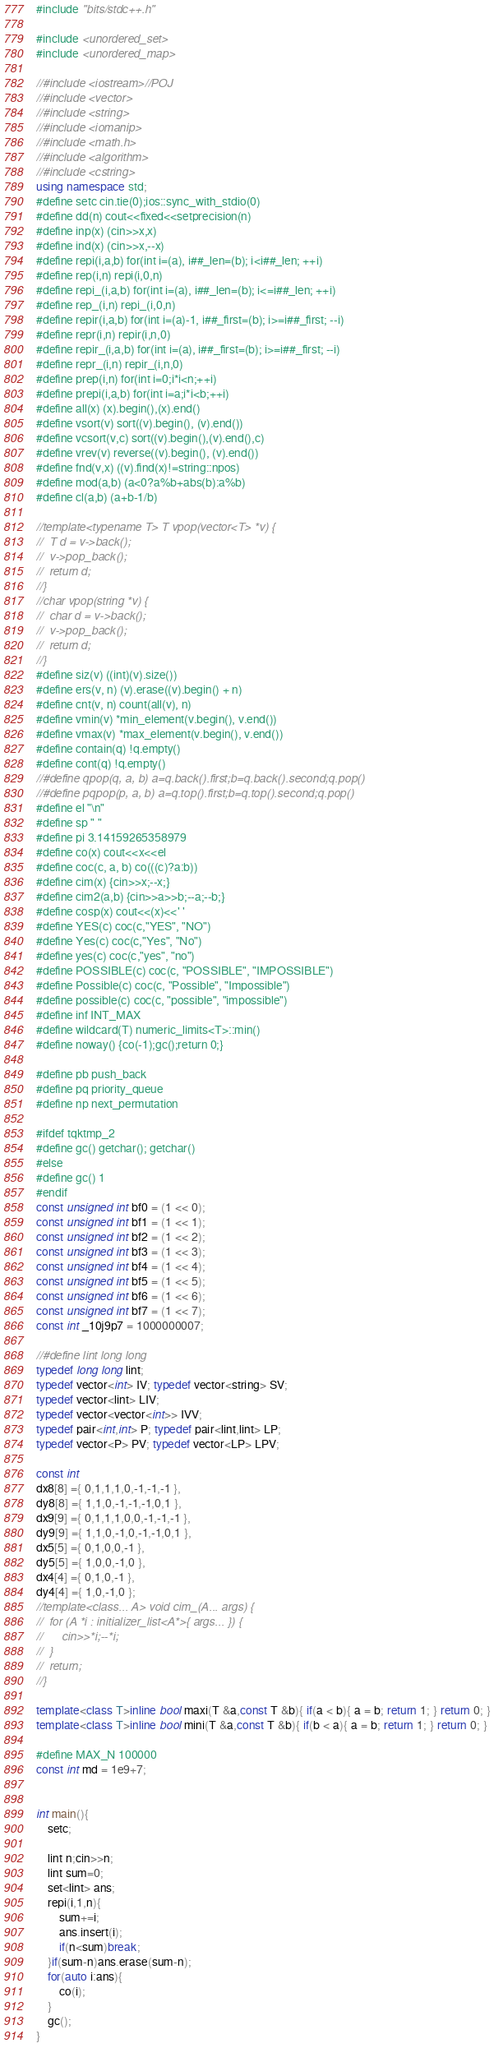Convert code to text. <code><loc_0><loc_0><loc_500><loc_500><_C++_>

#include "bits/stdc++.h"

#include <unordered_set>
#include <unordered_map>

//#include <iostream>//POJ
//#include <vector>
//#include <string>
//#include <iomanip>
//#include <math.h>
//#include <algorithm>
//#include <cstring>
using namespace std;
#define setc cin.tie(0);ios::sync_with_stdio(0)
#define dd(n) cout<<fixed<<setprecision(n)
#define inp(x) (cin>>x,x)
#define ind(x) (cin>>x,--x)
#define repi(i,a,b) for(int i=(a), i##_len=(b); i<i##_len; ++i)
#define rep(i,n) repi(i,0,n)
#define repi_(i,a,b) for(int i=(a), i##_len=(b); i<=i##_len; ++i)
#define rep_(i,n) repi_(i,0,n)
#define repir(i,a,b) for(int i=(a)-1, i##_first=(b); i>=i##_first; --i)
#define repr(i,n) repir(i,n,0)
#define repir_(i,a,b) for(int i=(a), i##_first=(b); i>=i##_first; --i)
#define repr_(i,n) repir_(i,n,0)
#define prep(i,n) for(int i=0;i*i<n;++i)
#define prepi(i,a,b) for(int i=a;i*i<b;++i)
#define all(x) (x).begin(),(x).end()
#define vsort(v) sort((v).begin(), (v).end())
#define vcsort(v,c) sort((v).begin(),(v).end(),c)
#define vrev(v) reverse((v).begin(), (v).end())
#define fnd(v,x) ((v).find(x)!=string::npos)
#define mod(a,b) (a<0?a%b+abs(b):a%b)
#define cl(a,b) (a+b-1/b)

//template<typename T> T vpop(vector<T> *v) {
//	T d = v->back();
//	v->pop_back();
//	return d;
//}
//char vpop(string *v) {
//	char d = v->back();
//	v->pop_back();
//	return d;
//}
#define siz(v) ((int)(v).size())
#define ers(v, n) (v).erase((v).begin() + n)
#define cnt(v, n) count(all(v), n)
#define vmin(v) *min_element(v.begin(), v.end())
#define vmax(v) *max_element(v.begin(), v.end())
#define contain(q) !q.empty()
#define cont(q) !q.empty()
//#define qpop(q, a, b) a=q.back().first;b=q.back().second;q.pop()
//#define pqpop(p, a, b) a=q.top().first;b=q.top().second;q.pop()
#define el "\n"
#define sp " "
#define pi 3.14159265358979
#define co(x) cout<<x<<el
#define coc(c, a, b) co(((c)?a:b))
#define cim(x) {cin>>x;--x;}
#define cim2(a,b) {cin>>a>>b;--a;--b;}
#define cosp(x) cout<<(x)<<' '
#define YES(c) coc(c,"YES", "NO")
#define Yes(c) coc(c,"Yes", "No")
#define yes(c) coc(c,"yes", "no")
#define POSSIBLE(c) coc(c, "POSSIBLE", "IMPOSSIBLE")
#define Possible(c) coc(c, "Possible", "Impossible")
#define possible(c) coc(c, "possible", "impossible")
#define inf INT_MAX
#define wildcard(T) numeric_limits<T>::min()
#define noway() {co(-1);gc();return 0;}

#define pb push_back
#define pq priority_queue
#define np next_permutation

#ifdef tqktmp_2
#define gc() getchar(); getchar()
#else
#define gc() 1
#endif
const unsigned int bf0 = (1 << 0);
const unsigned int bf1 = (1 << 1);
const unsigned int bf2 = (1 << 2);
const unsigned int bf3 = (1 << 3);
const unsigned int bf4 = (1 << 4);
const unsigned int bf5 = (1 << 5);
const unsigned int bf6 = (1 << 6);
const unsigned int bf7 = (1 << 7);
const int _10j9p7 = 1000000007;

//#define lint long long
typedef long long lint;
typedef vector<int> IV; typedef vector<string> SV;
typedef vector<lint> LIV;
typedef vector<vector<int>> IVV;
typedef pair<int,int> P; typedef pair<lint,lint> LP;
typedef vector<P> PV; typedef vector<LP> LPV;

const int
dx8[8] ={ 0,1,1,1,0,-1,-1,-1 },
dy8[8] ={ 1,1,0,-1,-1,-1,0,1 },
dx9[9] ={ 0,1,1,1,0,0,-1,-1,-1 },
dy9[9] ={ 1,1,0,-1,0,-1,-1,0,1 },
dx5[5] ={ 0,1,0,0,-1 },
dy5[5] ={ 1,0,0,-1,0 },
dx4[4] ={ 0,1,0,-1 },
dy4[4] ={ 1,0,-1,0 };
//template<class... A> void cim_(A... args) {
//	for (A *i : initializer_list<A*>{ args... }) {
//		cin>>*i;--*i;
//	}
//	return;
//}

template<class T>inline bool maxi(T &a,const T &b){ if(a < b){ a = b; return 1; } return 0; }
template<class T>inline bool mini(T &a,const T &b){ if(b < a){ a = b; return 1; } return 0; }

#define MAX_N 100000
const int md = 1e9+7;


int main(){
	setc;

	lint n;cin>>n;
	lint sum=0;
	set<lint> ans;
	repi(i,1,n){
		sum+=i;
		ans.insert(i);
		if(n<sum)break;
	}if(sum-n)ans.erase(sum-n);
	for(auto i:ans){
		co(i);
	}
	gc();
}</code> 